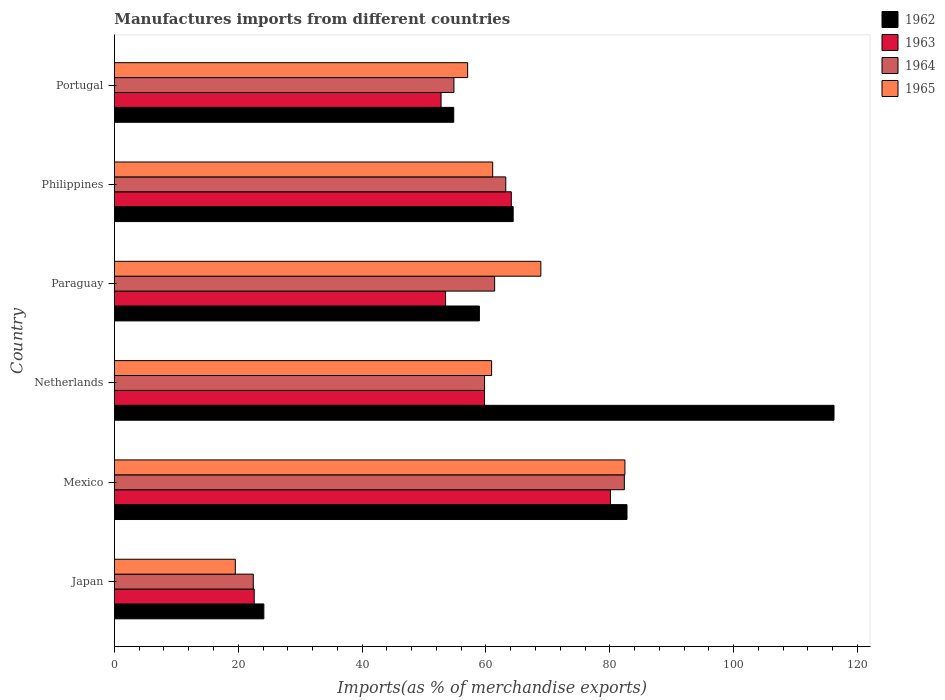How many different coloured bars are there?
Offer a terse response. 4. How many groups of bars are there?
Provide a short and direct response. 6. How many bars are there on the 1st tick from the top?
Your answer should be very brief. 4. How many bars are there on the 1st tick from the bottom?
Your answer should be very brief. 4. What is the percentage of imports to different countries in 1963 in Portugal?
Ensure brevity in your answer.  52.75. Across all countries, what is the maximum percentage of imports to different countries in 1964?
Offer a terse response. 82.35. Across all countries, what is the minimum percentage of imports to different countries in 1965?
Provide a short and direct response. 19.52. In which country was the percentage of imports to different countries in 1965 maximum?
Ensure brevity in your answer.  Mexico. In which country was the percentage of imports to different countries in 1963 minimum?
Offer a very short reply. Japan. What is the total percentage of imports to different countries in 1965 in the graph?
Offer a very short reply. 349.88. What is the difference between the percentage of imports to different countries in 1965 in Japan and that in Netherlands?
Make the answer very short. -41.39. What is the difference between the percentage of imports to different countries in 1964 in Netherlands and the percentage of imports to different countries in 1962 in Philippines?
Provide a succinct answer. -4.62. What is the average percentage of imports to different countries in 1964 per country?
Ensure brevity in your answer.  57.33. What is the difference between the percentage of imports to different countries in 1965 and percentage of imports to different countries in 1963 in Portugal?
Provide a succinct answer. 4.29. What is the ratio of the percentage of imports to different countries in 1963 in Japan to that in Paraguay?
Offer a terse response. 0.42. Is the difference between the percentage of imports to different countries in 1965 in Netherlands and Philippines greater than the difference between the percentage of imports to different countries in 1963 in Netherlands and Philippines?
Provide a succinct answer. Yes. What is the difference between the highest and the second highest percentage of imports to different countries in 1962?
Keep it short and to the point. 33.43. What is the difference between the highest and the lowest percentage of imports to different countries in 1965?
Provide a succinct answer. 62.92. Is the sum of the percentage of imports to different countries in 1965 in Mexico and Philippines greater than the maximum percentage of imports to different countries in 1963 across all countries?
Offer a terse response. Yes. What does the 1st bar from the top in Netherlands represents?
Provide a short and direct response. 1965. What does the 1st bar from the bottom in Japan represents?
Your answer should be very brief. 1962. Where does the legend appear in the graph?
Provide a short and direct response. Top right. What is the title of the graph?
Offer a very short reply. Manufactures imports from different countries. Does "2014" appear as one of the legend labels in the graph?
Give a very brief answer. No. What is the label or title of the X-axis?
Give a very brief answer. Imports(as % of merchandise exports). What is the Imports(as % of merchandise exports) of 1962 in Japan?
Provide a succinct answer. 24.13. What is the Imports(as % of merchandise exports) in 1963 in Japan?
Provide a succinct answer. 22.57. What is the Imports(as % of merchandise exports) in 1964 in Japan?
Your answer should be very brief. 22.43. What is the Imports(as % of merchandise exports) of 1965 in Japan?
Your answer should be compact. 19.52. What is the Imports(as % of merchandise exports) of 1962 in Mexico?
Your response must be concise. 82.78. What is the Imports(as % of merchandise exports) of 1963 in Mexico?
Your answer should be compact. 80.11. What is the Imports(as % of merchandise exports) in 1964 in Mexico?
Your answer should be very brief. 82.35. What is the Imports(as % of merchandise exports) of 1965 in Mexico?
Make the answer very short. 82.44. What is the Imports(as % of merchandise exports) in 1962 in Netherlands?
Offer a very short reply. 116.21. What is the Imports(as % of merchandise exports) of 1963 in Netherlands?
Make the answer very short. 59.77. What is the Imports(as % of merchandise exports) of 1964 in Netherlands?
Provide a succinct answer. 59.78. What is the Imports(as % of merchandise exports) of 1965 in Netherlands?
Ensure brevity in your answer.  60.91. What is the Imports(as % of merchandise exports) of 1962 in Paraguay?
Provide a succinct answer. 58.94. What is the Imports(as % of merchandise exports) in 1963 in Paraguay?
Your response must be concise. 53.48. What is the Imports(as % of merchandise exports) of 1964 in Paraguay?
Your response must be concise. 61.4. What is the Imports(as % of merchandise exports) in 1965 in Paraguay?
Make the answer very short. 68.86. What is the Imports(as % of merchandise exports) of 1962 in Philippines?
Give a very brief answer. 64.4. What is the Imports(as % of merchandise exports) in 1963 in Philippines?
Your answer should be compact. 64.1. What is the Imports(as % of merchandise exports) of 1964 in Philippines?
Provide a succinct answer. 63.2. What is the Imports(as % of merchandise exports) in 1965 in Philippines?
Offer a very short reply. 61.09. What is the Imports(as % of merchandise exports) in 1962 in Portugal?
Make the answer very short. 54.8. What is the Imports(as % of merchandise exports) of 1963 in Portugal?
Provide a short and direct response. 52.75. What is the Imports(as % of merchandise exports) in 1964 in Portugal?
Offer a very short reply. 54.83. What is the Imports(as % of merchandise exports) of 1965 in Portugal?
Provide a short and direct response. 57.04. Across all countries, what is the maximum Imports(as % of merchandise exports) of 1962?
Offer a terse response. 116.21. Across all countries, what is the maximum Imports(as % of merchandise exports) in 1963?
Keep it short and to the point. 80.11. Across all countries, what is the maximum Imports(as % of merchandise exports) in 1964?
Make the answer very short. 82.35. Across all countries, what is the maximum Imports(as % of merchandise exports) of 1965?
Ensure brevity in your answer.  82.44. Across all countries, what is the minimum Imports(as % of merchandise exports) in 1962?
Provide a short and direct response. 24.13. Across all countries, what is the minimum Imports(as % of merchandise exports) in 1963?
Offer a terse response. 22.57. Across all countries, what is the minimum Imports(as % of merchandise exports) in 1964?
Ensure brevity in your answer.  22.43. Across all countries, what is the minimum Imports(as % of merchandise exports) in 1965?
Provide a short and direct response. 19.52. What is the total Imports(as % of merchandise exports) of 1962 in the graph?
Provide a succinct answer. 401.26. What is the total Imports(as % of merchandise exports) in 1963 in the graph?
Offer a terse response. 332.78. What is the total Imports(as % of merchandise exports) of 1964 in the graph?
Provide a succinct answer. 343.99. What is the total Imports(as % of merchandise exports) of 1965 in the graph?
Provide a succinct answer. 349.88. What is the difference between the Imports(as % of merchandise exports) in 1962 in Japan and that in Mexico?
Ensure brevity in your answer.  -58.65. What is the difference between the Imports(as % of merchandise exports) of 1963 in Japan and that in Mexico?
Keep it short and to the point. -57.53. What is the difference between the Imports(as % of merchandise exports) in 1964 in Japan and that in Mexico?
Your answer should be very brief. -59.92. What is the difference between the Imports(as % of merchandise exports) in 1965 in Japan and that in Mexico?
Your response must be concise. -62.92. What is the difference between the Imports(as % of merchandise exports) of 1962 in Japan and that in Netherlands?
Provide a succinct answer. -92.08. What is the difference between the Imports(as % of merchandise exports) in 1963 in Japan and that in Netherlands?
Provide a succinct answer. -37.2. What is the difference between the Imports(as % of merchandise exports) of 1964 in Japan and that in Netherlands?
Provide a short and direct response. -37.35. What is the difference between the Imports(as % of merchandise exports) of 1965 in Japan and that in Netherlands?
Keep it short and to the point. -41.39. What is the difference between the Imports(as % of merchandise exports) in 1962 in Japan and that in Paraguay?
Make the answer very short. -34.81. What is the difference between the Imports(as % of merchandise exports) in 1963 in Japan and that in Paraguay?
Give a very brief answer. -30.91. What is the difference between the Imports(as % of merchandise exports) in 1964 in Japan and that in Paraguay?
Your answer should be very brief. -38.98. What is the difference between the Imports(as % of merchandise exports) of 1965 in Japan and that in Paraguay?
Give a very brief answer. -49.34. What is the difference between the Imports(as % of merchandise exports) of 1962 in Japan and that in Philippines?
Offer a terse response. -40.27. What is the difference between the Imports(as % of merchandise exports) in 1963 in Japan and that in Philippines?
Offer a terse response. -41.52. What is the difference between the Imports(as % of merchandise exports) in 1964 in Japan and that in Philippines?
Your answer should be very brief. -40.78. What is the difference between the Imports(as % of merchandise exports) in 1965 in Japan and that in Philippines?
Ensure brevity in your answer.  -41.56. What is the difference between the Imports(as % of merchandise exports) of 1962 in Japan and that in Portugal?
Your answer should be compact. -30.67. What is the difference between the Imports(as % of merchandise exports) in 1963 in Japan and that in Portugal?
Make the answer very short. -30.18. What is the difference between the Imports(as % of merchandise exports) in 1964 in Japan and that in Portugal?
Your answer should be very brief. -32.4. What is the difference between the Imports(as % of merchandise exports) of 1965 in Japan and that in Portugal?
Ensure brevity in your answer.  -37.52. What is the difference between the Imports(as % of merchandise exports) of 1962 in Mexico and that in Netherlands?
Offer a very short reply. -33.43. What is the difference between the Imports(as % of merchandise exports) in 1963 in Mexico and that in Netherlands?
Offer a very short reply. 20.34. What is the difference between the Imports(as % of merchandise exports) of 1964 in Mexico and that in Netherlands?
Keep it short and to the point. 22.57. What is the difference between the Imports(as % of merchandise exports) in 1965 in Mexico and that in Netherlands?
Offer a terse response. 21.53. What is the difference between the Imports(as % of merchandise exports) of 1962 in Mexico and that in Paraguay?
Your response must be concise. 23.83. What is the difference between the Imports(as % of merchandise exports) in 1963 in Mexico and that in Paraguay?
Make the answer very short. 26.63. What is the difference between the Imports(as % of merchandise exports) of 1964 in Mexico and that in Paraguay?
Your answer should be very brief. 20.95. What is the difference between the Imports(as % of merchandise exports) in 1965 in Mexico and that in Paraguay?
Make the answer very short. 13.58. What is the difference between the Imports(as % of merchandise exports) of 1962 in Mexico and that in Philippines?
Your answer should be very brief. 18.38. What is the difference between the Imports(as % of merchandise exports) in 1963 in Mexico and that in Philippines?
Offer a terse response. 16.01. What is the difference between the Imports(as % of merchandise exports) in 1964 in Mexico and that in Philippines?
Your response must be concise. 19.15. What is the difference between the Imports(as % of merchandise exports) of 1965 in Mexico and that in Philippines?
Provide a short and direct response. 21.36. What is the difference between the Imports(as % of merchandise exports) in 1962 in Mexico and that in Portugal?
Provide a short and direct response. 27.98. What is the difference between the Imports(as % of merchandise exports) in 1963 in Mexico and that in Portugal?
Provide a succinct answer. 27.36. What is the difference between the Imports(as % of merchandise exports) of 1964 in Mexico and that in Portugal?
Ensure brevity in your answer.  27.52. What is the difference between the Imports(as % of merchandise exports) in 1965 in Mexico and that in Portugal?
Ensure brevity in your answer.  25.4. What is the difference between the Imports(as % of merchandise exports) of 1962 in Netherlands and that in Paraguay?
Provide a succinct answer. 57.27. What is the difference between the Imports(as % of merchandise exports) of 1963 in Netherlands and that in Paraguay?
Make the answer very short. 6.29. What is the difference between the Imports(as % of merchandise exports) of 1964 in Netherlands and that in Paraguay?
Give a very brief answer. -1.63. What is the difference between the Imports(as % of merchandise exports) of 1965 in Netherlands and that in Paraguay?
Your answer should be very brief. -7.95. What is the difference between the Imports(as % of merchandise exports) of 1962 in Netherlands and that in Philippines?
Your response must be concise. 51.81. What is the difference between the Imports(as % of merchandise exports) in 1963 in Netherlands and that in Philippines?
Keep it short and to the point. -4.33. What is the difference between the Imports(as % of merchandise exports) of 1964 in Netherlands and that in Philippines?
Your response must be concise. -3.42. What is the difference between the Imports(as % of merchandise exports) of 1965 in Netherlands and that in Philippines?
Make the answer very short. -0.17. What is the difference between the Imports(as % of merchandise exports) of 1962 in Netherlands and that in Portugal?
Provide a succinct answer. 61.41. What is the difference between the Imports(as % of merchandise exports) of 1963 in Netherlands and that in Portugal?
Provide a succinct answer. 7.02. What is the difference between the Imports(as % of merchandise exports) in 1964 in Netherlands and that in Portugal?
Your answer should be compact. 4.95. What is the difference between the Imports(as % of merchandise exports) of 1965 in Netherlands and that in Portugal?
Provide a succinct answer. 3.87. What is the difference between the Imports(as % of merchandise exports) of 1962 in Paraguay and that in Philippines?
Offer a very short reply. -5.45. What is the difference between the Imports(as % of merchandise exports) of 1963 in Paraguay and that in Philippines?
Your answer should be very brief. -10.62. What is the difference between the Imports(as % of merchandise exports) of 1964 in Paraguay and that in Philippines?
Provide a succinct answer. -1.8. What is the difference between the Imports(as % of merchandise exports) of 1965 in Paraguay and that in Philippines?
Ensure brevity in your answer.  7.78. What is the difference between the Imports(as % of merchandise exports) in 1962 in Paraguay and that in Portugal?
Make the answer very short. 4.15. What is the difference between the Imports(as % of merchandise exports) in 1963 in Paraguay and that in Portugal?
Keep it short and to the point. 0.73. What is the difference between the Imports(as % of merchandise exports) in 1964 in Paraguay and that in Portugal?
Your answer should be compact. 6.57. What is the difference between the Imports(as % of merchandise exports) of 1965 in Paraguay and that in Portugal?
Give a very brief answer. 11.82. What is the difference between the Imports(as % of merchandise exports) of 1962 in Philippines and that in Portugal?
Ensure brevity in your answer.  9.6. What is the difference between the Imports(as % of merchandise exports) of 1963 in Philippines and that in Portugal?
Make the answer very short. 11.35. What is the difference between the Imports(as % of merchandise exports) in 1964 in Philippines and that in Portugal?
Your answer should be compact. 8.37. What is the difference between the Imports(as % of merchandise exports) of 1965 in Philippines and that in Portugal?
Give a very brief answer. 4.04. What is the difference between the Imports(as % of merchandise exports) of 1962 in Japan and the Imports(as % of merchandise exports) of 1963 in Mexico?
Your response must be concise. -55.98. What is the difference between the Imports(as % of merchandise exports) of 1962 in Japan and the Imports(as % of merchandise exports) of 1964 in Mexico?
Your response must be concise. -58.22. What is the difference between the Imports(as % of merchandise exports) in 1962 in Japan and the Imports(as % of merchandise exports) in 1965 in Mexico?
Ensure brevity in your answer.  -58.32. What is the difference between the Imports(as % of merchandise exports) of 1963 in Japan and the Imports(as % of merchandise exports) of 1964 in Mexico?
Make the answer very short. -59.78. What is the difference between the Imports(as % of merchandise exports) in 1963 in Japan and the Imports(as % of merchandise exports) in 1965 in Mexico?
Offer a very short reply. -59.87. What is the difference between the Imports(as % of merchandise exports) in 1964 in Japan and the Imports(as % of merchandise exports) in 1965 in Mexico?
Give a very brief answer. -60.02. What is the difference between the Imports(as % of merchandise exports) in 1962 in Japan and the Imports(as % of merchandise exports) in 1963 in Netherlands?
Your answer should be very brief. -35.64. What is the difference between the Imports(as % of merchandise exports) of 1962 in Japan and the Imports(as % of merchandise exports) of 1964 in Netherlands?
Offer a very short reply. -35.65. What is the difference between the Imports(as % of merchandise exports) of 1962 in Japan and the Imports(as % of merchandise exports) of 1965 in Netherlands?
Provide a short and direct response. -36.79. What is the difference between the Imports(as % of merchandise exports) of 1963 in Japan and the Imports(as % of merchandise exports) of 1964 in Netherlands?
Provide a short and direct response. -37.2. What is the difference between the Imports(as % of merchandise exports) in 1963 in Japan and the Imports(as % of merchandise exports) in 1965 in Netherlands?
Ensure brevity in your answer.  -38.34. What is the difference between the Imports(as % of merchandise exports) of 1964 in Japan and the Imports(as % of merchandise exports) of 1965 in Netherlands?
Provide a succinct answer. -38.49. What is the difference between the Imports(as % of merchandise exports) in 1962 in Japan and the Imports(as % of merchandise exports) in 1963 in Paraguay?
Provide a short and direct response. -29.35. What is the difference between the Imports(as % of merchandise exports) of 1962 in Japan and the Imports(as % of merchandise exports) of 1964 in Paraguay?
Your answer should be very brief. -37.28. What is the difference between the Imports(as % of merchandise exports) of 1962 in Japan and the Imports(as % of merchandise exports) of 1965 in Paraguay?
Give a very brief answer. -44.74. What is the difference between the Imports(as % of merchandise exports) in 1963 in Japan and the Imports(as % of merchandise exports) in 1964 in Paraguay?
Ensure brevity in your answer.  -38.83. What is the difference between the Imports(as % of merchandise exports) in 1963 in Japan and the Imports(as % of merchandise exports) in 1965 in Paraguay?
Offer a terse response. -46.29. What is the difference between the Imports(as % of merchandise exports) in 1964 in Japan and the Imports(as % of merchandise exports) in 1965 in Paraguay?
Your response must be concise. -46.44. What is the difference between the Imports(as % of merchandise exports) in 1962 in Japan and the Imports(as % of merchandise exports) in 1963 in Philippines?
Your answer should be compact. -39.97. What is the difference between the Imports(as % of merchandise exports) in 1962 in Japan and the Imports(as % of merchandise exports) in 1964 in Philippines?
Give a very brief answer. -39.07. What is the difference between the Imports(as % of merchandise exports) of 1962 in Japan and the Imports(as % of merchandise exports) of 1965 in Philippines?
Your answer should be compact. -36.96. What is the difference between the Imports(as % of merchandise exports) in 1963 in Japan and the Imports(as % of merchandise exports) in 1964 in Philippines?
Ensure brevity in your answer.  -40.63. What is the difference between the Imports(as % of merchandise exports) of 1963 in Japan and the Imports(as % of merchandise exports) of 1965 in Philippines?
Give a very brief answer. -38.51. What is the difference between the Imports(as % of merchandise exports) in 1964 in Japan and the Imports(as % of merchandise exports) in 1965 in Philippines?
Your response must be concise. -38.66. What is the difference between the Imports(as % of merchandise exports) of 1962 in Japan and the Imports(as % of merchandise exports) of 1963 in Portugal?
Keep it short and to the point. -28.62. What is the difference between the Imports(as % of merchandise exports) in 1962 in Japan and the Imports(as % of merchandise exports) in 1964 in Portugal?
Your response must be concise. -30.7. What is the difference between the Imports(as % of merchandise exports) in 1962 in Japan and the Imports(as % of merchandise exports) in 1965 in Portugal?
Your answer should be very brief. -32.91. What is the difference between the Imports(as % of merchandise exports) of 1963 in Japan and the Imports(as % of merchandise exports) of 1964 in Portugal?
Your response must be concise. -32.26. What is the difference between the Imports(as % of merchandise exports) in 1963 in Japan and the Imports(as % of merchandise exports) in 1965 in Portugal?
Make the answer very short. -34.47. What is the difference between the Imports(as % of merchandise exports) of 1964 in Japan and the Imports(as % of merchandise exports) of 1965 in Portugal?
Your answer should be compact. -34.62. What is the difference between the Imports(as % of merchandise exports) of 1962 in Mexico and the Imports(as % of merchandise exports) of 1963 in Netherlands?
Provide a short and direct response. 23.01. What is the difference between the Imports(as % of merchandise exports) in 1962 in Mexico and the Imports(as % of merchandise exports) in 1964 in Netherlands?
Provide a succinct answer. 23. What is the difference between the Imports(as % of merchandise exports) in 1962 in Mexico and the Imports(as % of merchandise exports) in 1965 in Netherlands?
Provide a short and direct response. 21.86. What is the difference between the Imports(as % of merchandise exports) of 1963 in Mexico and the Imports(as % of merchandise exports) of 1964 in Netherlands?
Your answer should be very brief. 20.33. What is the difference between the Imports(as % of merchandise exports) of 1963 in Mexico and the Imports(as % of merchandise exports) of 1965 in Netherlands?
Keep it short and to the point. 19.19. What is the difference between the Imports(as % of merchandise exports) of 1964 in Mexico and the Imports(as % of merchandise exports) of 1965 in Netherlands?
Make the answer very short. 21.44. What is the difference between the Imports(as % of merchandise exports) in 1962 in Mexico and the Imports(as % of merchandise exports) in 1963 in Paraguay?
Provide a short and direct response. 29.3. What is the difference between the Imports(as % of merchandise exports) in 1962 in Mexico and the Imports(as % of merchandise exports) in 1964 in Paraguay?
Provide a short and direct response. 21.37. What is the difference between the Imports(as % of merchandise exports) of 1962 in Mexico and the Imports(as % of merchandise exports) of 1965 in Paraguay?
Your response must be concise. 13.91. What is the difference between the Imports(as % of merchandise exports) of 1963 in Mexico and the Imports(as % of merchandise exports) of 1964 in Paraguay?
Offer a very short reply. 18.7. What is the difference between the Imports(as % of merchandise exports) of 1963 in Mexico and the Imports(as % of merchandise exports) of 1965 in Paraguay?
Your response must be concise. 11.24. What is the difference between the Imports(as % of merchandise exports) in 1964 in Mexico and the Imports(as % of merchandise exports) in 1965 in Paraguay?
Your answer should be very brief. 13.49. What is the difference between the Imports(as % of merchandise exports) in 1962 in Mexico and the Imports(as % of merchandise exports) in 1963 in Philippines?
Ensure brevity in your answer.  18.68. What is the difference between the Imports(as % of merchandise exports) in 1962 in Mexico and the Imports(as % of merchandise exports) in 1964 in Philippines?
Your answer should be very brief. 19.57. What is the difference between the Imports(as % of merchandise exports) of 1962 in Mexico and the Imports(as % of merchandise exports) of 1965 in Philippines?
Provide a short and direct response. 21.69. What is the difference between the Imports(as % of merchandise exports) in 1963 in Mexico and the Imports(as % of merchandise exports) in 1964 in Philippines?
Make the answer very short. 16.9. What is the difference between the Imports(as % of merchandise exports) of 1963 in Mexico and the Imports(as % of merchandise exports) of 1965 in Philippines?
Offer a very short reply. 19.02. What is the difference between the Imports(as % of merchandise exports) in 1964 in Mexico and the Imports(as % of merchandise exports) in 1965 in Philippines?
Ensure brevity in your answer.  21.26. What is the difference between the Imports(as % of merchandise exports) in 1962 in Mexico and the Imports(as % of merchandise exports) in 1963 in Portugal?
Provide a short and direct response. 30.03. What is the difference between the Imports(as % of merchandise exports) in 1962 in Mexico and the Imports(as % of merchandise exports) in 1964 in Portugal?
Your response must be concise. 27.95. What is the difference between the Imports(as % of merchandise exports) in 1962 in Mexico and the Imports(as % of merchandise exports) in 1965 in Portugal?
Provide a short and direct response. 25.73. What is the difference between the Imports(as % of merchandise exports) of 1963 in Mexico and the Imports(as % of merchandise exports) of 1964 in Portugal?
Your response must be concise. 25.28. What is the difference between the Imports(as % of merchandise exports) of 1963 in Mexico and the Imports(as % of merchandise exports) of 1965 in Portugal?
Provide a succinct answer. 23.06. What is the difference between the Imports(as % of merchandise exports) in 1964 in Mexico and the Imports(as % of merchandise exports) in 1965 in Portugal?
Your response must be concise. 25.31. What is the difference between the Imports(as % of merchandise exports) of 1962 in Netherlands and the Imports(as % of merchandise exports) of 1963 in Paraguay?
Keep it short and to the point. 62.73. What is the difference between the Imports(as % of merchandise exports) in 1962 in Netherlands and the Imports(as % of merchandise exports) in 1964 in Paraguay?
Offer a terse response. 54.81. What is the difference between the Imports(as % of merchandise exports) of 1962 in Netherlands and the Imports(as % of merchandise exports) of 1965 in Paraguay?
Keep it short and to the point. 47.35. What is the difference between the Imports(as % of merchandise exports) of 1963 in Netherlands and the Imports(as % of merchandise exports) of 1964 in Paraguay?
Offer a terse response. -1.63. What is the difference between the Imports(as % of merchandise exports) in 1963 in Netherlands and the Imports(as % of merchandise exports) in 1965 in Paraguay?
Provide a short and direct response. -9.09. What is the difference between the Imports(as % of merchandise exports) of 1964 in Netherlands and the Imports(as % of merchandise exports) of 1965 in Paraguay?
Offer a terse response. -9.09. What is the difference between the Imports(as % of merchandise exports) in 1962 in Netherlands and the Imports(as % of merchandise exports) in 1963 in Philippines?
Offer a terse response. 52.11. What is the difference between the Imports(as % of merchandise exports) of 1962 in Netherlands and the Imports(as % of merchandise exports) of 1964 in Philippines?
Give a very brief answer. 53.01. What is the difference between the Imports(as % of merchandise exports) in 1962 in Netherlands and the Imports(as % of merchandise exports) in 1965 in Philippines?
Provide a short and direct response. 55.12. What is the difference between the Imports(as % of merchandise exports) in 1963 in Netherlands and the Imports(as % of merchandise exports) in 1964 in Philippines?
Provide a succinct answer. -3.43. What is the difference between the Imports(as % of merchandise exports) in 1963 in Netherlands and the Imports(as % of merchandise exports) in 1965 in Philippines?
Provide a succinct answer. -1.32. What is the difference between the Imports(as % of merchandise exports) of 1964 in Netherlands and the Imports(as % of merchandise exports) of 1965 in Philippines?
Provide a short and direct response. -1.31. What is the difference between the Imports(as % of merchandise exports) in 1962 in Netherlands and the Imports(as % of merchandise exports) in 1963 in Portugal?
Your response must be concise. 63.46. What is the difference between the Imports(as % of merchandise exports) in 1962 in Netherlands and the Imports(as % of merchandise exports) in 1964 in Portugal?
Your response must be concise. 61.38. What is the difference between the Imports(as % of merchandise exports) in 1962 in Netherlands and the Imports(as % of merchandise exports) in 1965 in Portugal?
Offer a very short reply. 59.17. What is the difference between the Imports(as % of merchandise exports) in 1963 in Netherlands and the Imports(as % of merchandise exports) in 1964 in Portugal?
Provide a short and direct response. 4.94. What is the difference between the Imports(as % of merchandise exports) of 1963 in Netherlands and the Imports(as % of merchandise exports) of 1965 in Portugal?
Your response must be concise. 2.73. What is the difference between the Imports(as % of merchandise exports) in 1964 in Netherlands and the Imports(as % of merchandise exports) in 1965 in Portugal?
Give a very brief answer. 2.74. What is the difference between the Imports(as % of merchandise exports) in 1962 in Paraguay and the Imports(as % of merchandise exports) in 1963 in Philippines?
Your response must be concise. -5.15. What is the difference between the Imports(as % of merchandise exports) of 1962 in Paraguay and the Imports(as % of merchandise exports) of 1964 in Philippines?
Offer a terse response. -4.26. What is the difference between the Imports(as % of merchandise exports) in 1962 in Paraguay and the Imports(as % of merchandise exports) in 1965 in Philippines?
Provide a succinct answer. -2.14. What is the difference between the Imports(as % of merchandise exports) of 1963 in Paraguay and the Imports(as % of merchandise exports) of 1964 in Philippines?
Your answer should be compact. -9.72. What is the difference between the Imports(as % of merchandise exports) in 1963 in Paraguay and the Imports(as % of merchandise exports) in 1965 in Philippines?
Offer a very short reply. -7.61. What is the difference between the Imports(as % of merchandise exports) in 1964 in Paraguay and the Imports(as % of merchandise exports) in 1965 in Philippines?
Offer a very short reply. 0.32. What is the difference between the Imports(as % of merchandise exports) in 1962 in Paraguay and the Imports(as % of merchandise exports) in 1963 in Portugal?
Your answer should be compact. 6.19. What is the difference between the Imports(as % of merchandise exports) of 1962 in Paraguay and the Imports(as % of merchandise exports) of 1964 in Portugal?
Offer a terse response. 4.11. What is the difference between the Imports(as % of merchandise exports) of 1962 in Paraguay and the Imports(as % of merchandise exports) of 1965 in Portugal?
Your answer should be very brief. 1.9. What is the difference between the Imports(as % of merchandise exports) in 1963 in Paraguay and the Imports(as % of merchandise exports) in 1964 in Portugal?
Your response must be concise. -1.35. What is the difference between the Imports(as % of merchandise exports) of 1963 in Paraguay and the Imports(as % of merchandise exports) of 1965 in Portugal?
Your response must be concise. -3.56. What is the difference between the Imports(as % of merchandise exports) of 1964 in Paraguay and the Imports(as % of merchandise exports) of 1965 in Portugal?
Your answer should be very brief. 4.36. What is the difference between the Imports(as % of merchandise exports) in 1962 in Philippines and the Imports(as % of merchandise exports) in 1963 in Portugal?
Give a very brief answer. 11.65. What is the difference between the Imports(as % of merchandise exports) of 1962 in Philippines and the Imports(as % of merchandise exports) of 1964 in Portugal?
Keep it short and to the point. 9.57. What is the difference between the Imports(as % of merchandise exports) in 1962 in Philippines and the Imports(as % of merchandise exports) in 1965 in Portugal?
Your response must be concise. 7.35. What is the difference between the Imports(as % of merchandise exports) in 1963 in Philippines and the Imports(as % of merchandise exports) in 1964 in Portugal?
Offer a very short reply. 9.27. What is the difference between the Imports(as % of merchandise exports) in 1963 in Philippines and the Imports(as % of merchandise exports) in 1965 in Portugal?
Your answer should be very brief. 7.05. What is the difference between the Imports(as % of merchandise exports) of 1964 in Philippines and the Imports(as % of merchandise exports) of 1965 in Portugal?
Give a very brief answer. 6.16. What is the average Imports(as % of merchandise exports) of 1962 per country?
Give a very brief answer. 66.88. What is the average Imports(as % of merchandise exports) in 1963 per country?
Make the answer very short. 55.46. What is the average Imports(as % of merchandise exports) in 1964 per country?
Your response must be concise. 57.33. What is the average Imports(as % of merchandise exports) of 1965 per country?
Provide a short and direct response. 58.31. What is the difference between the Imports(as % of merchandise exports) of 1962 and Imports(as % of merchandise exports) of 1963 in Japan?
Make the answer very short. 1.55. What is the difference between the Imports(as % of merchandise exports) in 1962 and Imports(as % of merchandise exports) in 1964 in Japan?
Offer a terse response. 1.7. What is the difference between the Imports(as % of merchandise exports) in 1962 and Imports(as % of merchandise exports) in 1965 in Japan?
Give a very brief answer. 4.6. What is the difference between the Imports(as % of merchandise exports) in 1963 and Imports(as % of merchandise exports) in 1964 in Japan?
Your answer should be very brief. 0.15. What is the difference between the Imports(as % of merchandise exports) in 1963 and Imports(as % of merchandise exports) in 1965 in Japan?
Offer a terse response. 3.05. What is the difference between the Imports(as % of merchandise exports) in 1964 and Imports(as % of merchandise exports) in 1965 in Japan?
Ensure brevity in your answer.  2.9. What is the difference between the Imports(as % of merchandise exports) in 1962 and Imports(as % of merchandise exports) in 1963 in Mexico?
Ensure brevity in your answer.  2.67. What is the difference between the Imports(as % of merchandise exports) in 1962 and Imports(as % of merchandise exports) in 1964 in Mexico?
Offer a terse response. 0.43. What is the difference between the Imports(as % of merchandise exports) in 1962 and Imports(as % of merchandise exports) in 1965 in Mexico?
Your response must be concise. 0.33. What is the difference between the Imports(as % of merchandise exports) in 1963 and Imports(as % of merchandise exports) in 1964 in Mexico?
Offer a very short reply. -2.24. What is the difference between the Imports(as % of merchandise exports) in 1963 and Imports(as % of merchandise exports) in 1965 in Mexico?
Offer a very short reply. -2.34. What is the difference between the Imports(as % of merchandise exports) in 1964 and Imports(as % of merchandise exports) in 1965 in Mexico?
Offer a very short reply. -0.09. What is the difference between the Imports(as % of merchandise exports) of 1962 and Imports(as % of merchandise exports) of 1963 in Netherlands?
Offer a very short reply. 56.44. What is the difference between the Imports(as % of merchandise exports) in 1962 and Imports(as % of merchandise exports) in 1964 in Netherlands?
Keep it short and to the point. 56.43. What is the difference between the Imports(as % of merchandise exports) in 1962 and Imports(as % of merchandise exports) in 1965 in Netherlands?
Your response must be concise. 55.3. What is the difference between the Imports(as % of merchandise exports) of 1963 and Imports(as % of merchandise exports) of 1964 in Netherlands?
Offer a terse response. -0.01. What is the difference between the Imports(as % of merchandise exports) in 1963 and Imports(as % of merchandise exports) in 1965 in Netherlands?
Your response must be concise. -1.14. What is the difference between the Imports(as % of merchandise exports) in 1964 and Imports(as % of merchandise exports) in 1965 in Netherlands?
Your answer should be compact. -1.14. What is the difference between the Imports(as % of merchandise exports) in 1962 and Imports(as % of merchandise exports) in 1963 in Paraguay?
Give a very brief answer. 5.46. What is the difference between the Imports(as % of merchandise exports) in 1962 and Imports(as % of merchandise exports) in 1964 in Paraguay?
Provide a succinct answer. -2.46. What is the difference between the Imports(as % of merchandise exports) of 1962 and Imports(as % of merchandise exports) of 1965 in Paraguay?
Keep it short and to the point. -9.92. What is the difference between the Imports(as % of merchandise exports) of 1963 and Imports(as % of merchandise exports) of 1964 in Paraguay?
Offer a terse response. -7.92. What is the difference between the Imports(as % of merchandise exports) in 1963 and Imports(as % of merchandise exports) in 1965 in Paraguay?
Your answer should be compact. -15.38. What is the difference between the Imports(as % of merchandise exports) in 1964 and Imports(as % of merchandise exports) in 1965 in Paraguay?
Give a very brief answer. -7.46. What is the difference between the Imports(as % of merchandise exports) of 1962 and Imports(as % of merchandise exports) of 1963 in Philippines?
Make the answer very short. 0.3. What is the difference between the Imports(as % of merchandise exports) of 1962 and Imports(as % of merchandise exports) of 1964 in Philippines?
Make the answer very short. 1.19. What is the difference between the Imports(as % of merchandise exports) of 1962 and Imports(as % of merchandise exports) of 1965 in Philippines?
Your answer should be compact. 3.31. What is the difference between the Imports(as % of merchandise exports) of 1963 and Imports(as % of merchandise exports) of 1964 in Philippines?
Keep it short and to the point. 0.89. What is the difference between the Imports(as % of merchandise exports) in 1963 and Imports(as % of merchandise exports) in 1965 in Philippines?
Offer a terse response. 3.01. What is the difference between the Imports(as % of merchandise exports) in 1964 and Imports(as % of merchandise exports) in 1965 in Philippines?
Give a very brief answer. 2.12. What is the difference between the Imports(as % of merchandise exports) in 1962 and Imports(as % of merchandise exports) in 1963 in Portugal?
Your answer should be very brief. 2.05. What is the difference between the Imports(as % of merchandise exports) of 1962 and Imports(as % of merchandise exports) of 1964 in Portugal?
Provide a short and direct response. -0.03. What is the difference between the Imports(as % of merchandise exports) of 1962 and Imports(as % of merchandise exports) of 1965 in Portugal?
Make the answer very short. -2.24. What is the difference between the Imports(as % of merchandise exports) in 1963 and Imports(as % of merchandise exports) in 1964 in Portugal?
Offer a very short reply. -2.08. What is the difference between the Imports(as % of merchandise exports) in 1963 and Imports(as % of merchandise exports) in 1965 in Portugal?
Offer a very short reply. -4.29. What is the difference between the Imports(as % of merchandise exports) of 1964 and Imports(as % of merchandise exports) of 1965 in Portugal?
Provide a short and direct response. -2.21. What is the ratio of the Imports(as % of merchandise exports) in 1962 in Japan to that in Mexico?
Your answer should be compact. 0.29. What is the ratio of the Imports(as % of merchandise exports) of 1963 in Japan to that in Mexico?
Offer a very short reply. 0.28. What is the ratio of the Imports(as % of merchandise exports) of 1964 in Japan to that in Mexico?
Offer a very short reply. 0.27. What is the ratio of the Imports(as % of merchandise exports) of 1965 in Japan to that in Mexico?
Keep it short and to the point. 0.24. What is the ratio of the Imports(as % of merchandise exports) of 1962 in Japan to that in Netherlands?
Your answer should be compact. 0.21. What is the ratio of the Imports(as % of merchandise exports) of 1963 in Japan to that in Netherlands?
Give a very brief answer. 0.38. What is the ratio of the Imports(as % of merchandise exports) in 1964 in Japan to that in Netherlands?
Provide a short and direct response. 0.38. What is the ratio of the Imports(as % of merchandise exports) in 1965 in Japan to that in Netherlands?
Ensure brevity in your answer.  0.32. What is the ratio of the Imports(as % of merchandise exports) of 1962 in Japan to that in Paraguay?
Make the answer very short. 0.41. What is the ratio of the Imports(as % of merchandise exports) in 1963 in Japan to that in Paraguay?
Offer a terse response. 0.42. What is the ratio of the Imports(as % of merchandise exports) in 1964 in Japan to that in Paraguay?
Keep it short and to the point. 0.37. What is the ratio of the Imports(as % of merchandise exports) in 1965 in Japan to that in Paraguay?
Offer a very short reply. 0.28. What is the ratio of the Imports(as % of merchandise exports) of 1962 in Japan to that in Philippines?
Keep it short and to the point. 0.37. What is the ratio of the Imports(as % of merchandise exports) in 1963 in Japan to that in Philippines?
Offer a terse response. 0.35. What is the ratio of the Imports(as % of merchandise exports) in 1964 in Japan to that in Philippines?
Offer a very short reply. 0.35. What is the ratio of the Imports(as % of merchandise exports) of 1965 in Japan to that in Philippines?
Your answer should be compact. 0.32. What is the ratio of the Imports(as % of merchandise exports) of 1962 in Japan to that in Portugal?
Provide a succinct answer. 0.44. What is the ratio of the Imports(as % of merchandise exports) in 1963 in Japan to that in Portugal?
Provide a succinct answer. 0.43. What is the ratio of the Imports(as % of merchandise exports) in 1964 in Japan to that in Portugal?
Ensure brevity in your answer.  0.41. What is the ratio of the Imports(as % of merchandise exports) of 1965 in Japan to that in Portugal?
Offer a very short reply. 0.34. What is the ratio of the Imports(as % of merchandise exports) in 1962 in Mexico to that in Netherlands?
Your answer should be compact. 0.71. What is the ratio of the Imports(as % of merchandise exports) in 1963 in Mexico to that in Netherlands?
Your answer should be very brief. 1.34. What is the ratio of the Imports(as % of merchandise exports) in 1964 in Mexico to that in Netherlands?
Offer a terse response. 1.38. What is the ratio of the Imports(as % of merchandise exports) in 1965 in Mexico to that in Netherlands?
Make the answer very short. 1.35. What is the ratio of the Imports(as % of merchandise exports) of 1962 in Mexico to that in Paraguay?
Offer a terse response. 1.4. What is the ratio of the Imports(as % of merchandise exports) in 1963 in Mexico to that in Paraguay?
Give a very brief answer. 1.5. What is the ratio of the Imports(as % of merchandise exports) in 1964 in Mexico to that in Paraguay?
Keep it short and to the point. 1.34. What is the ratio of the Imports(as % of merchandise exports) of 1965 in Mexico to that in Paraguay?
Your response must be concise. 1.2. What is the ratio of the Imports(as % of merchandise exports) of 1962 in Mexico to that in Philippines?
Make the answer very short. 1.29. What is the ratio of the Imports(as % of merchandise exports) of 1963 in Mexico to that in Philippines?
Your answer should be compact. 1.25. What is the ratio of the Imports(as % of merchandise exports) of 1964 in Mexico to that in Philippines?
Provide a succinct answer. 1.3. What is the ratio of the Imports(as % of merchandise exports) of 1965 in Mexico to that in Philippines?
Keep it short and to the point. 1.35. What is the ratio of the Imports(as % of merchandise exports) of 1962 in Mexico to that in Portugal?
Keep it short and to the point. 1.51. What is the ratio of the Imports(as % of merchandise exports) of 1963 in Mexico to that in Portugal?
Make the answer very short. 1.52. What is the ratio of the Imports(as % of merchandise exports) in 1964 in Mexico to that in Portugal?
Provide a succinct answer. 1.5. What is the ratio of the Imports(as % of merchandise exports) of 1965 in Mexico to that in Portugal?
Ensure brevity in your answer.  1.45. What is the ratio of the Imports(as % of merchandise exports) in 1962 in Netherlands to that in Paraguay?
Keep it short and to the point. 1.97. What is the ratio of the Imports(as % of merchandise exports) of 1963 in Netherlands to that in Paraguay?
Your answer should be compact. 1.12. What is the ratio of the Imports(as % of merchandise exports) of 1964 in Netherlands to that in Paraguay?
Offer a terse response. 0.97. What is the ratio of the Imports(as % of merchandise exports) of 1965 in Netherlands to that in Paraguay?
Give a very brief answer. 0.88. What is the ratio of the Imports(as % of merchandise exports) in 1962 in Netherlands to that in Philippines?
Your answer should be compact. 1.8. What is the ratio of the Imports(as % of merchandise exports) in 1963 in Netherlands to that in Philippines?
Give a very brief answer. 0.93. What is the ratio of the Imports(as % of merchandise exports) of 1964 in Netherlands to that in Philippines?
Give a very brief answer. 0.95. What is the ratio of the Imports(as % of merchandise exports) in 1965 in Netherlands to that in Philippines?
Make the answer very short. 1. What is the ratio of the Imports(as % of merchandise exports) of 1962 in Netherlands to that in Portugal?
Keep it short and to the point. 2.12. What is the ratio of the Imports(as % of merchandise exports) of 1963 in Netherlands to that in Portugal?
Ensure brevity in your answer.  1.13. What is the ratio of the Imports(as % of merchandise exports) of 1964 in Netherlands to that in Portugal?
Give a very brief answer. 1.09. What is the ratio of the Imports(as % of merchandise exports) in 1965 in Netherlands to that in Portugal?
Offer a very short reply. 1.07. What is the ratio of the Imports(as % of merchandise exports) in 1962 in Paraguay to that in Philippines?
Keep it short and to the point. 0.92. What is the ratio of the Imports(as % of merchandise exports) of 1963 in Paraguay to that in Philippines?
Your answer should be very brief. 0.83. What is the ratio of the Imports(as % of merchandise exports) of 1964 in Paraguay to that in Philippines?
Keep it short and to the point. 0.97. What is the ratio of the Imports(as % of merchandise exports) of 1965 in Paraguay to that in Philippines?
Your answer should be compact. 1.13. What is the ratio of the Imports(as % of merchandise exports) of 1962 in Paraguay to that in Portugal?
Offer a very short reply. 1.08. What is the ratio of the Imports(as % of merchandise exports) of 1963 in Paraguay to that in Portugal?
Offer a very short reply. 1.01. What is the ratio of the Imports(as % of merchandise exports) of 1964 in Paraguay to that in Portugal?
Keep it short and to the point. 1.12. What is the ratio of the Imports(as % of merchandise exports) of 1965 in Paraguay to that in Portugal?
Ensure brevity in your answer.  1.21. What is the ratio of the Imports(as % of merchandise exports) of 1962 in Philippines to that in Portugal?
Make the answer very short. 1.18. What is the ratio of the Imports(as % of merchandise exports) in 1963 in Philippines to that in Portugal?
Your answer should be compact. 1.22. What is the ratio of the Imports(as % of merchandise exports) of 1964 in Philippines to that in Portugal?
Offer a very short reply. 1.15. What is the ratio of the Imports(as % of merchandise exports) in 1965 in Philippines to that in Portugal?
Give a very brief answer. 1.07. What is the difference between the highest and the second highest Imports(as % of merchandise exports) in 1962?
Ensure brevity in your answer.  33.43. What is the difference between the highest and the second highest Imports(as % of merchandise exports) in 1963?
Give a very brief answer. 16.01. What is the difference between the highest and the second highest Imports(as % of merchandise exports) in 1964?
Your answer should be compact. 19.15. What is the difference between the highest and the second highest Imports(as % of merchandise exports) in 1965?
Ensure brevity in your answer.  13.58. What is the difference between the highest and the lowest Imports(as % of merchandise exports) of 1962?
Provide a succinct answer. 92.08. What is the difference between the highest and the lowest Imports(as % of merchandise exports) in 1963?
Provide a succinct answer. 57.53. What is the difference between the highest and the lowest Imports(as % of merchandise exports) of 1964?
Give a very brief answer. 59.92. What is the difference between the highest and the lowest Imports(as % of merchandise exports) of 1965?
Give a very brief answer. 62.92. 